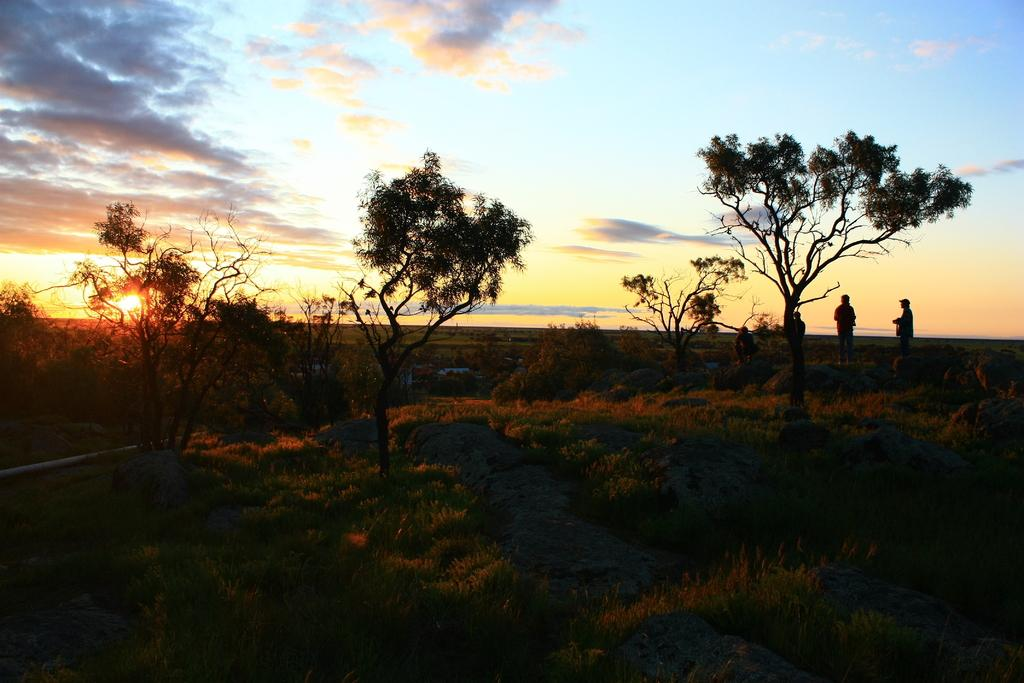What are the people in the image doing? The people in the image are standing on stones. What type of vegetation can be seen in the image? There is grass visible in the image, and there are also trees. What is the weather like in the image? The sky appears cloudy in the image, and the sun is visible, suggesting a mix of sun and clouds. What type of wool is being spun by the parent in the image? There is no parent or wool present in the image; it features people standing on stones with grass, trees, and a cloudy sky. 